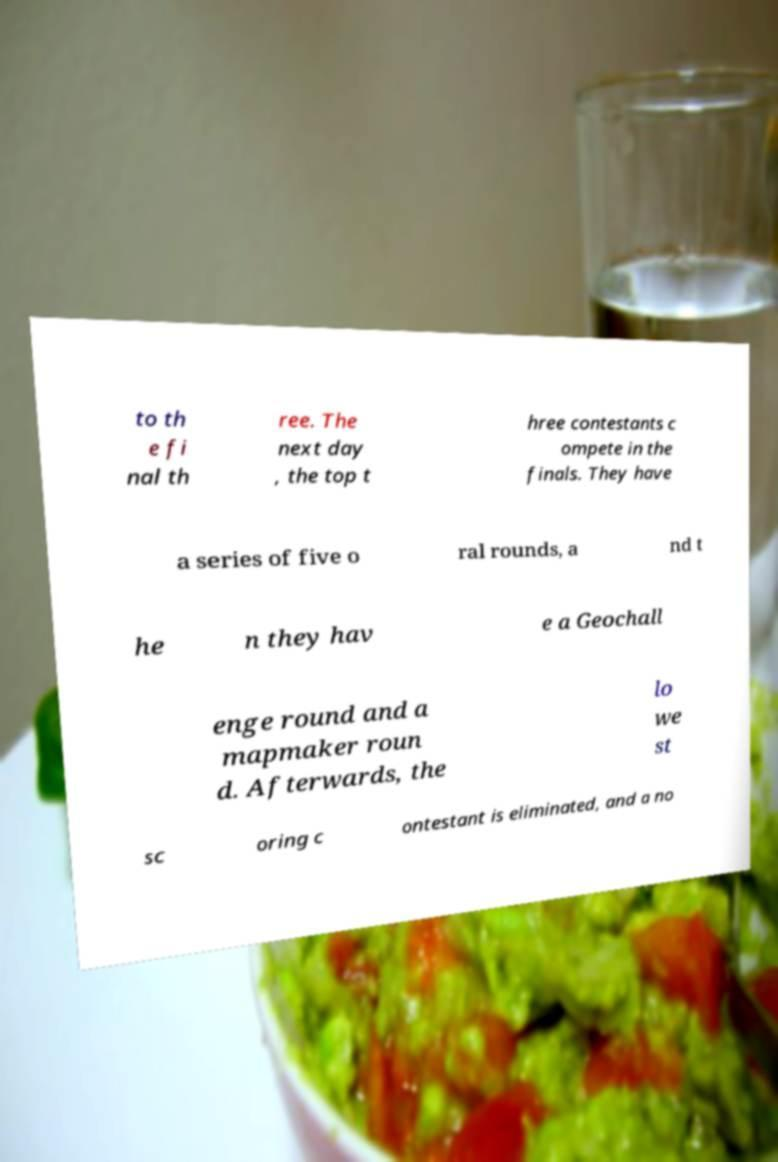Could you assist in decoding the text presented in this image and type it out clearly? to th e fi nal th ree. The next day , the top t hree contestants c ompete in the finals. They have a series of five o ral rounds, a nd t he n they hav e a Geochall enge round and a mapmaker roun d. Afterwards, the lo we st sc oring c ontestant is eliminated, and a no 